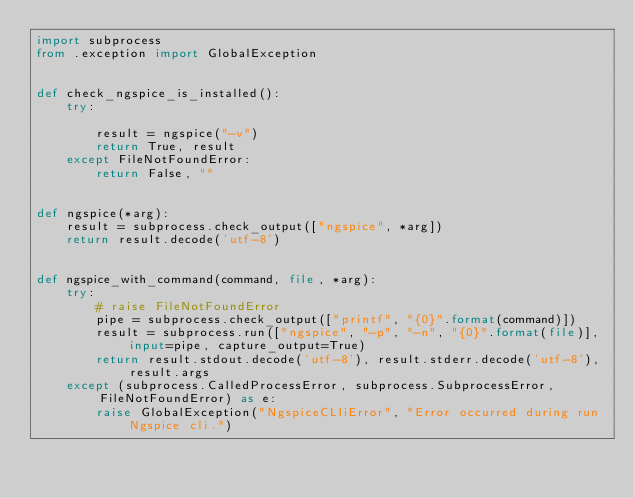<code> <loc_0><loc_0><loc_500><loc_500><_Python_>import subprocess
from .exception import GlobalException


def check_ngspice_is_installed():
    try:

        result = ngspice("-v")
        return True, result
    except FileNotFoundError:
        return False, ""


def ngspice(*arg):
    result = subprocess.check_output(["ngspice", *arg])
    return result.decode('utf-8')


def ngspice_with_command(command, file, *arg):
    try:
        # raise FileNotFoundError
        pipe = subprocess.check_output(["printf", "{0}".format(command)])
        result = subprocess.run(["ngspice", "-p", "-n", "{0}".format(file)], input=pipe, capture_output=True)
        return result.stdout.decode('utf-8'), result.stderr.decode('utf-8'), result.args
    except (subprocess.CalledProcessError, subprocess.SubprocessError, FileNotFoundError) as e:
        raise GlobalException("NgspiceCLIiError", "Error occurred during run Ngspice cli.")
</code> 